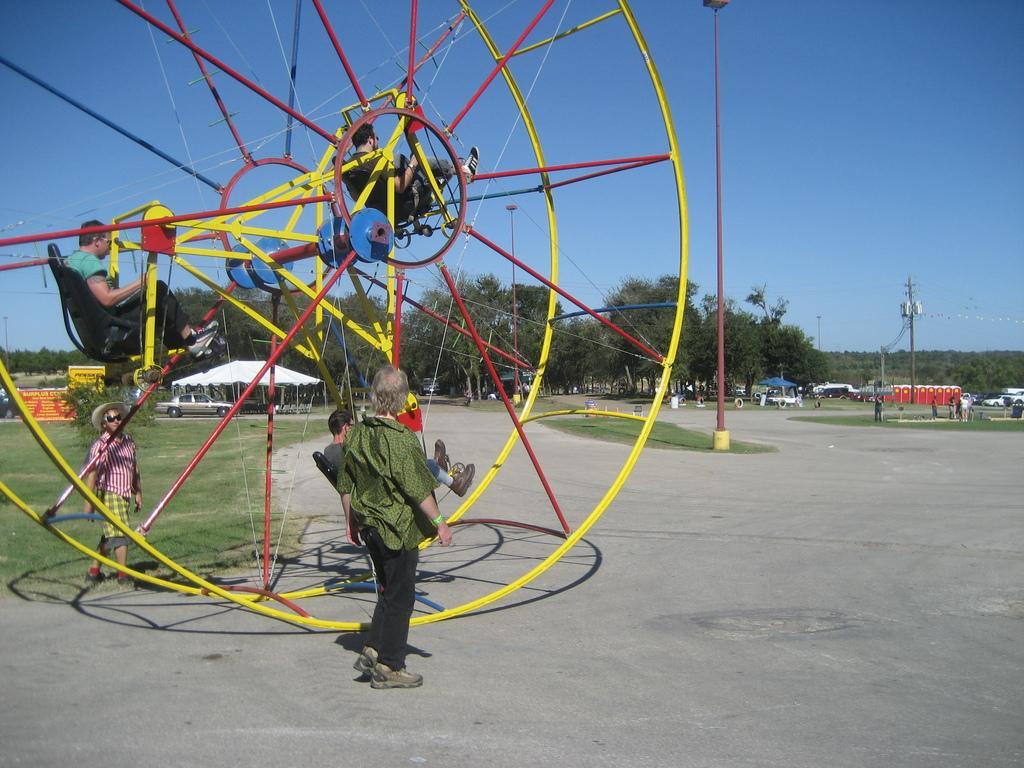Please provide a concise description of this image. In this image we can see people sitting in a fun ride. There is a person standing. In the background of the image there are trees, cars, electric poles. At the bottom of the image there is road. 